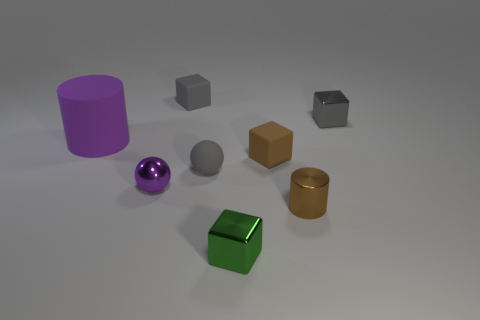What number of other things are there of the same color as the large thing?
Give a very brief answer. 1. There is a shiny thing that is behind the small gray rubber sphere; is it the same color as the rubber sphere?
Your answer should be compact. Yes. There is a cylinder that is the same color as the metal ball; what is its size?
Your response must be concise. Large. There is another tiny rubber thing that is the same shape as the tiny purple thing; what color is it?
Keep it short and to the point. Gray. There is a cylinder behind the brown shiny object; is there a gray metallic thing that is behind it?
Offer a very short reply. Yes. Do the small gray thing that is in front of the purple rubber object and the small gray metallic thing have the same shape?
Offer a very short reply. No. The small purple thing has what shape?
Offer a very short reply. Sphere. How many small cylinders are the same material as the brown cube?
Offer a very short reply. 0. There is a large matte object; does it have the same color as the block in front of the purple metal object?
Your response must be concise. No. How many green shiny blocks are there?
Ensure brevity in your answer.  1. 